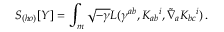Convert formula to latex. <formula><loc_0><loc_0><loc_500><loc_500>S _ { ( h o ) } [ Y ] = \int _ { m } \sqrt { - \gamma } L ( \gamma ^ { a b } , K _ { a b ^ { i } , \widetilde { \nabla } _ { a } K _ { b c ^ { i } ) \, .</formula> 